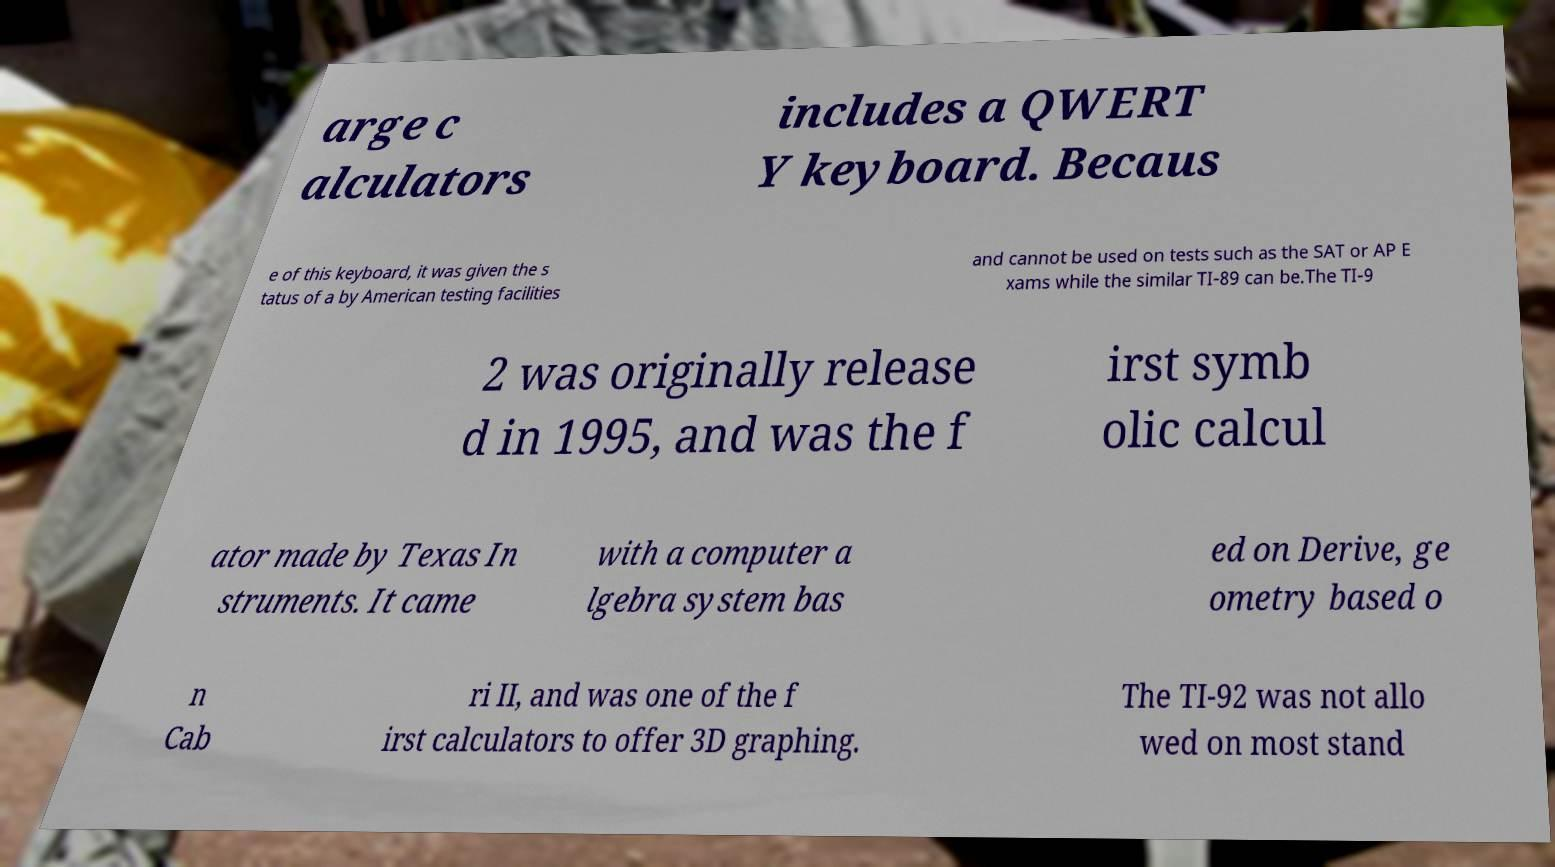Could you assist in decoding the text presented in this image and type it out clearly? arge c alculators includes a QWERT Y keyboard. Becaus e of this keyboard, it was given the s tatus of a by American testing facilities and cannot be used on tests such as the SAT or AP E xams while the similar TI-89 can be.The TI-9 2 was originally release d in 1995, and was the f irst symb olic calcul ator made by Texas In struments. It came with a computer a lgebra system bas ed on Derive, ge ometry based o n Cab ri II, and was one of the f irst calculators to offer 3D graphing. The TI-92 was not allo wed on most stand 